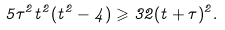Convert formula to latex. <formula><loc_0><loc_0><loc_500><loc_500>5 \tau ^ { 2 } t ^ { 2 } ( t ^ { 2 } - 4 ) \geqslant 3 2 ( t + \tau ) ^ { 2 } .</formula> 